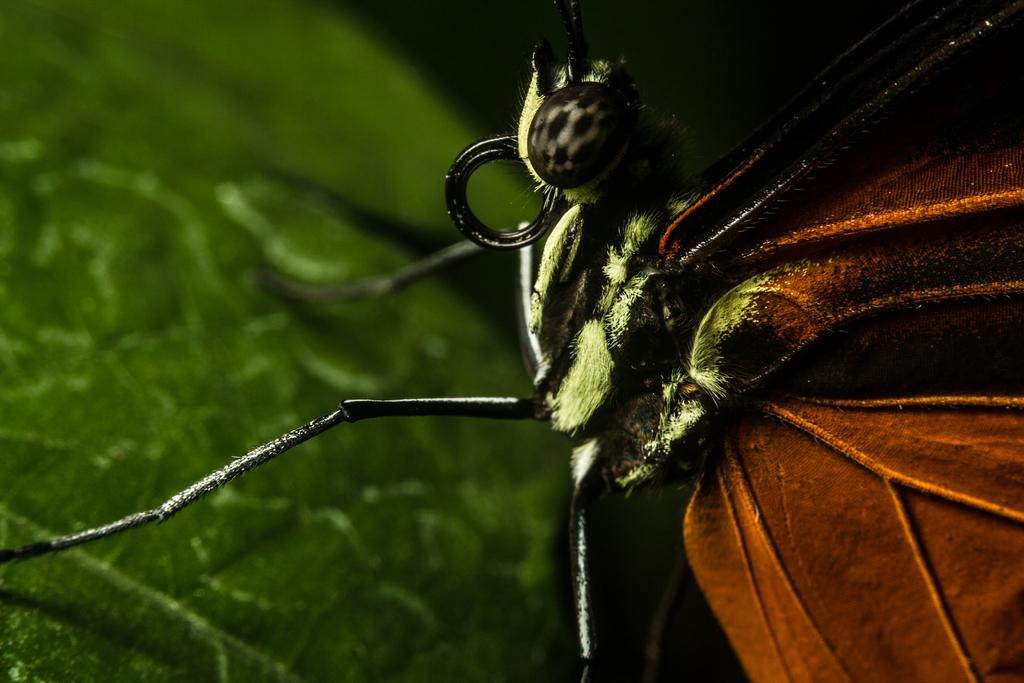What is the main subject of the image? The main subject of the image is an insect's upper body. Where is the insect located in the image? The insect is on a green leaf. What is the insect's tendency to process numbers in the image? There is no indication in the image that the insect has any tendency to process numbers. 